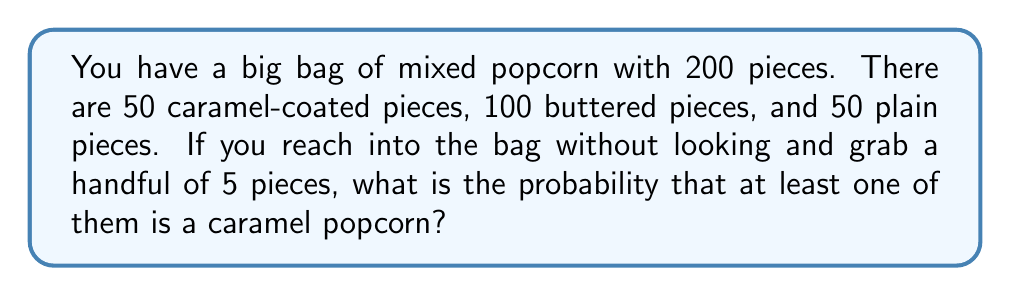Show me your answer to this math problem. Let's approach this step-by-step:

1) First, let's calculate the probability of NOT getting a caramel popcorn in a single draw:
   $$P(\text{not caramel}) = \frac{150}{200} = \frac{3}{4}$$

2) For all 5 draws to not be caramel, this needs to happen 5 times in a row:
   $$P(\text{all 5 not caramel}) = (\frac{3}{4})^5 = \frac{243}{1024}$$

3) Therefore, the probability of getting at least one caramel popcorn is the opposite of this:
   $$P(\text{at least one caramel}) = 1 - P(\text{all 5 not caramel})$$
   $$= 1 - \frac{243}{1024} = \frac{1024 - 243}{1024} = \frac{781}{1024}$$

4) This can be simplified by dividing both numerator and denominator by 781:
   $$\frac{781}{1024} = \frac{1}{1.31114...} \approx 0.7627$$

So, there's about a 76.27% chance of getting at least one caramel popcorn in a handful of 5.
Answer: $\frac{781}{1024}$ or approximately $0.7627$ or $76.27\%$ 